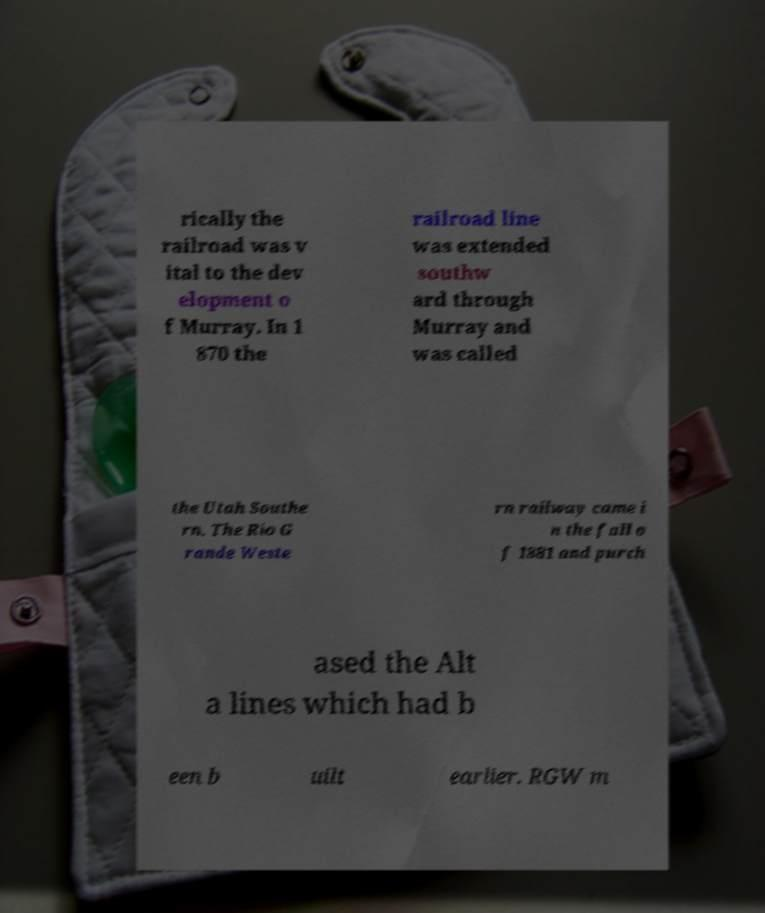Can you read and provide the text displayed in the image?This photo seems to have some interesting text. Can you extract and type it out for me? rically the railroad was v ital to the dev elopment o f Murray. In 1 870 the railroad line was extended southw ard through Murray and was called the Utah Southe rn. The Rio G rande Weste rn railway came i n the fall o f 1881 and purch ased the Alt a lines which had b een b uilt earlier. RGW m 